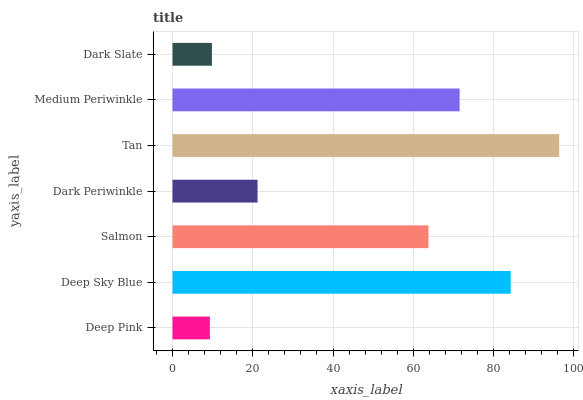Is Deep Pink the minimum?
Answer yes or no. Yes. Is Tan the maximum?
Answer yes or no. Yes. Is Deep Sky Blue the minimum?
Answer yes or no. No. Is Deep Sky Blue the maximum?
Answer yes or no. No. Is Deep Sky Blue greater than Deep Pink?
Answer yes or no. Yes. Is Deep Pink less than Deep Sky Blue?
Answer yes or no. Yes. Is Deep Pink greater than Deep Sky Blue?
Answer yes or no. No. Is Deep Sky Blue less than Deep Pink?
Answer yes or no. No. Is Salmon the high median?
Answer yes or no. Yes. Is Salmon the low median?
Answer yes or no. Yes. Is Tan the high median?
Answer yes or no. No. Is Deep Sky Blue the low median?
Answer yes or no. No. 